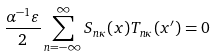Convert formula to latex. <formula><loc_0><loc_0><loc_500><loc_500>\frac { \alpha ^ { - 1 } \varepsilon } { 2 } \sum _ { n = - \infty } ^ { \infty } S _ { n \kappa } ( x ) T _ { n \kappa } ( x ^ { \prime } ) = 0</formula> 